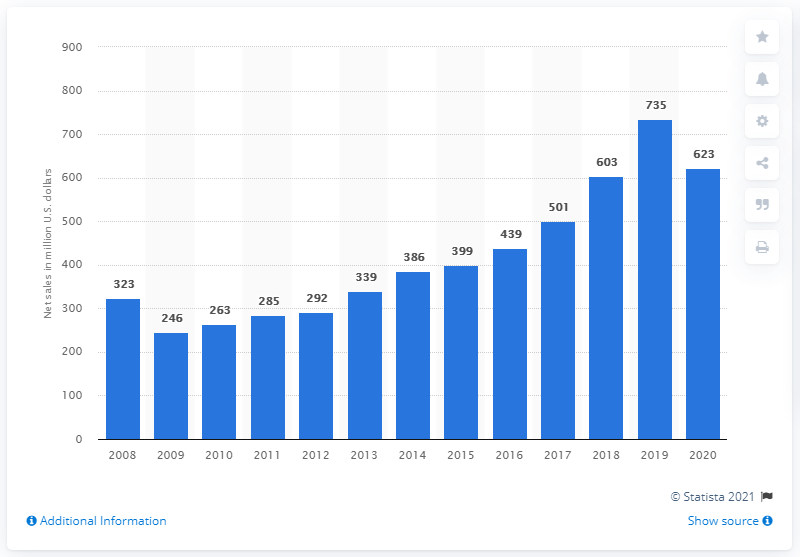Identify some key points in this picture. In 2020, Garmin's net sales in the aviation segment were 623 million. In the prior year, Garmin's sales in the aviation segment were approximately 735. 